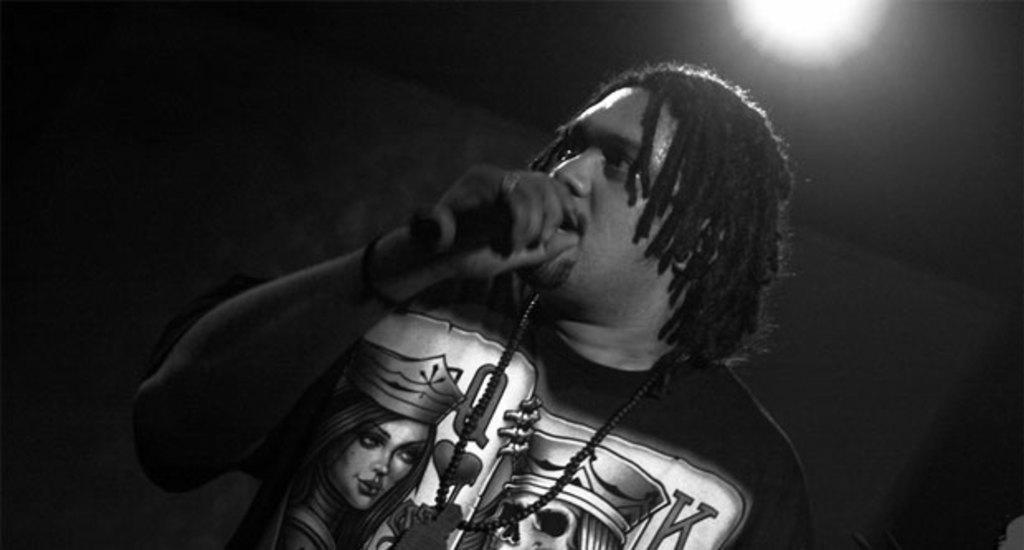Please provide a concise description of this image. In this image we can see there is a person standing and holding a mic. And there is a dark background. 